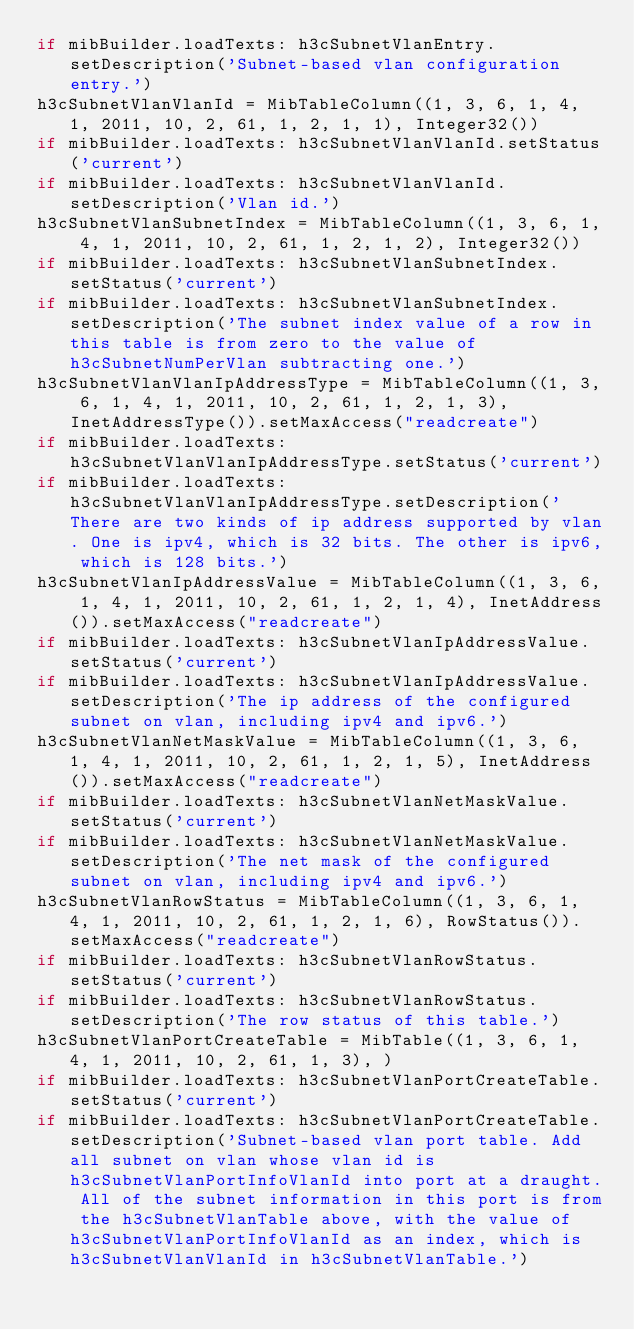<code> <loc_0><loc_0><loc_500><loc_500><_Python_>if mibBuilder.loadTexts: h3cSubnetVlanEntry.setDescription('Subnet-based vlan configuration entry.')
h3cSubnetVlanVlanId = MibTableColumn((1, 3, 6, 1, 4, 1, 2011, 10, 2, 61, 1, 2, 1, 1), Integer32())
if mibBuilder.loadTexts: h3cSubnetVlanVlanId.setStatus('current')
if mibBuilder.loadTexts: h3cSubnetVlanVlanId.setDescription('Vlan id.')
h3cSubnetVlanSubnetIndex = MibTableColumn((1, 3, 6, 1, 4, 1, 2011, 10, 2, 61, 1, 2, 1, 2), Integer32())
if mibBuilder.loadTexts: h3cSubnetVlanSubnetIndex.setStatus('current')
if mibBuilder.loadTexts: h3cSubnetVlanSubnetIndex.setDescription('The subnet index value of a row in this table is from zero to the value of h3cSubnetNumPerVlan subtracting one.')
h3cSubnetVlanVlanIpAddressType = MibTableColumn((1, 3, 6, 1, 4, 1, 2011, 10, 2, 61, 1, 2, 1, 3), InetAddressType()).setMaxAccess("readcreate")
if mibBuilder.loadTexts: h3cSubnetVlanVlanIpAddressType.setStatus('current')
if mibBuilder.loadTexts: h3cSubnetVlanVlanIpAddressType.setDescription('There are two kinds of ip address supported by vlan. One is ipv4, which is 32 bits. The other is ipv6, which is 128 bits.')
h3cSubnetVlanIpAddressValue = MibTableColumn((1, 3, 6, 1, 4, 1, 2011, 10, 2, 61, 1, 2, 1, 4), InetAddress()).setMaxAccess("readcreate")
if mibBuilder.loadTexts: h3cSubnetVlanIpAddressValue.setStatus('current')
if mibBuilder.loadTexts: h3cSubnetVlanIpAddressValue.setDescription('The ip address of the configured subnet on vlan, including ipv4 and ipv6.')
h3cSubnetVlanNetMaskValue = MibTableColumn((1, 3, 6, 1, 4, 1, 2011, 10, 2, 61, 1, 2, 1, 5), InetAddress()).setMaxAccess("readcreate")
if mibBuilder.loadTexts: h3cSubnetVlanNetMaskValue.setStatus('current')
if mibBuilder.loadTexts: h3cSubnetVlanNetMaskValue.setDescription('The net mask of the configured subnet on vlan, including ipv4 and ipv6.')
h3cSubnetVlanRowStatus = MibTableColumn((1, 3, 6, 1, 4, 1, 2011, 10, 2, 61, 1, 2, 1, 6), RowStatus()).setMaxAccess("readcreate")
if mibBuilder.loadTexts: h3cSubnetVlanRowStatus.setStatus('current')
if mibBuilder.loadTexts: h3cSubnetVlanRowStatus.setDescription('The row status of this table.')
h3cSubnetVlanPortCreateTable = MibTable((1, 3, 6, 1, 4, 1, 2011, 10, 2, 61, 1, 3), )
if mibBuilder.loadTexts: h3cSubnetVlanPortCreateTable.setStatus('current')
if mibBuilder.loadTexts: h3cSubnetVlanPortCreateTable.setDescription('Subnet-based vlan port table. Add all subnet on vlan whose vlan id is h3cSubnetVlanPortInfoVlanId into port at a draught. All of the subnet information in this port is from the h3cSubnetVlanTable above, with the value of h3cSubnetVlanPortInfoVlanId as an index, which is h3cSubnetVlanVlanId in h3cSubnetVlanTable.')</code> 